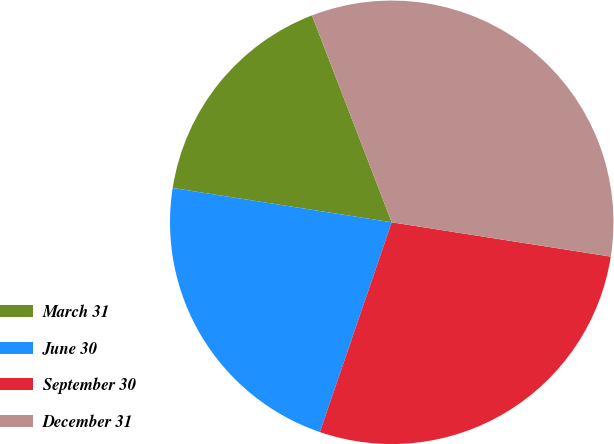Convert chart. <chart><loc_0><loc_0><loc_500><loc_500><pie_chart><fcel>March 31<fcel>June 30<fcel>September 30<fcel>December 31<nl><fcel>16.67%<fcel>22.22%<fcel>27.78%<fcel>33.33%<nl></chart> 